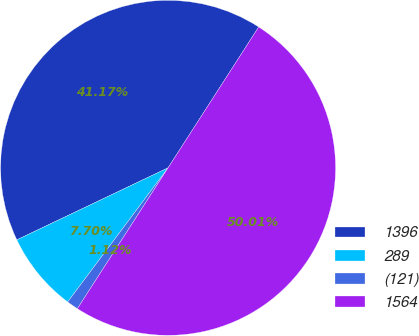Convert chart to OTSL. <chart><loc_0><loc_0><loc_500><loc_500><pie_chart><fcel>1396<fcel>289<fcel>(121)<fcel>1564<nl><fcel>41.17%<fcel>7.7%<fcel>1.12%<fcel>50.0%<nl></chart> 